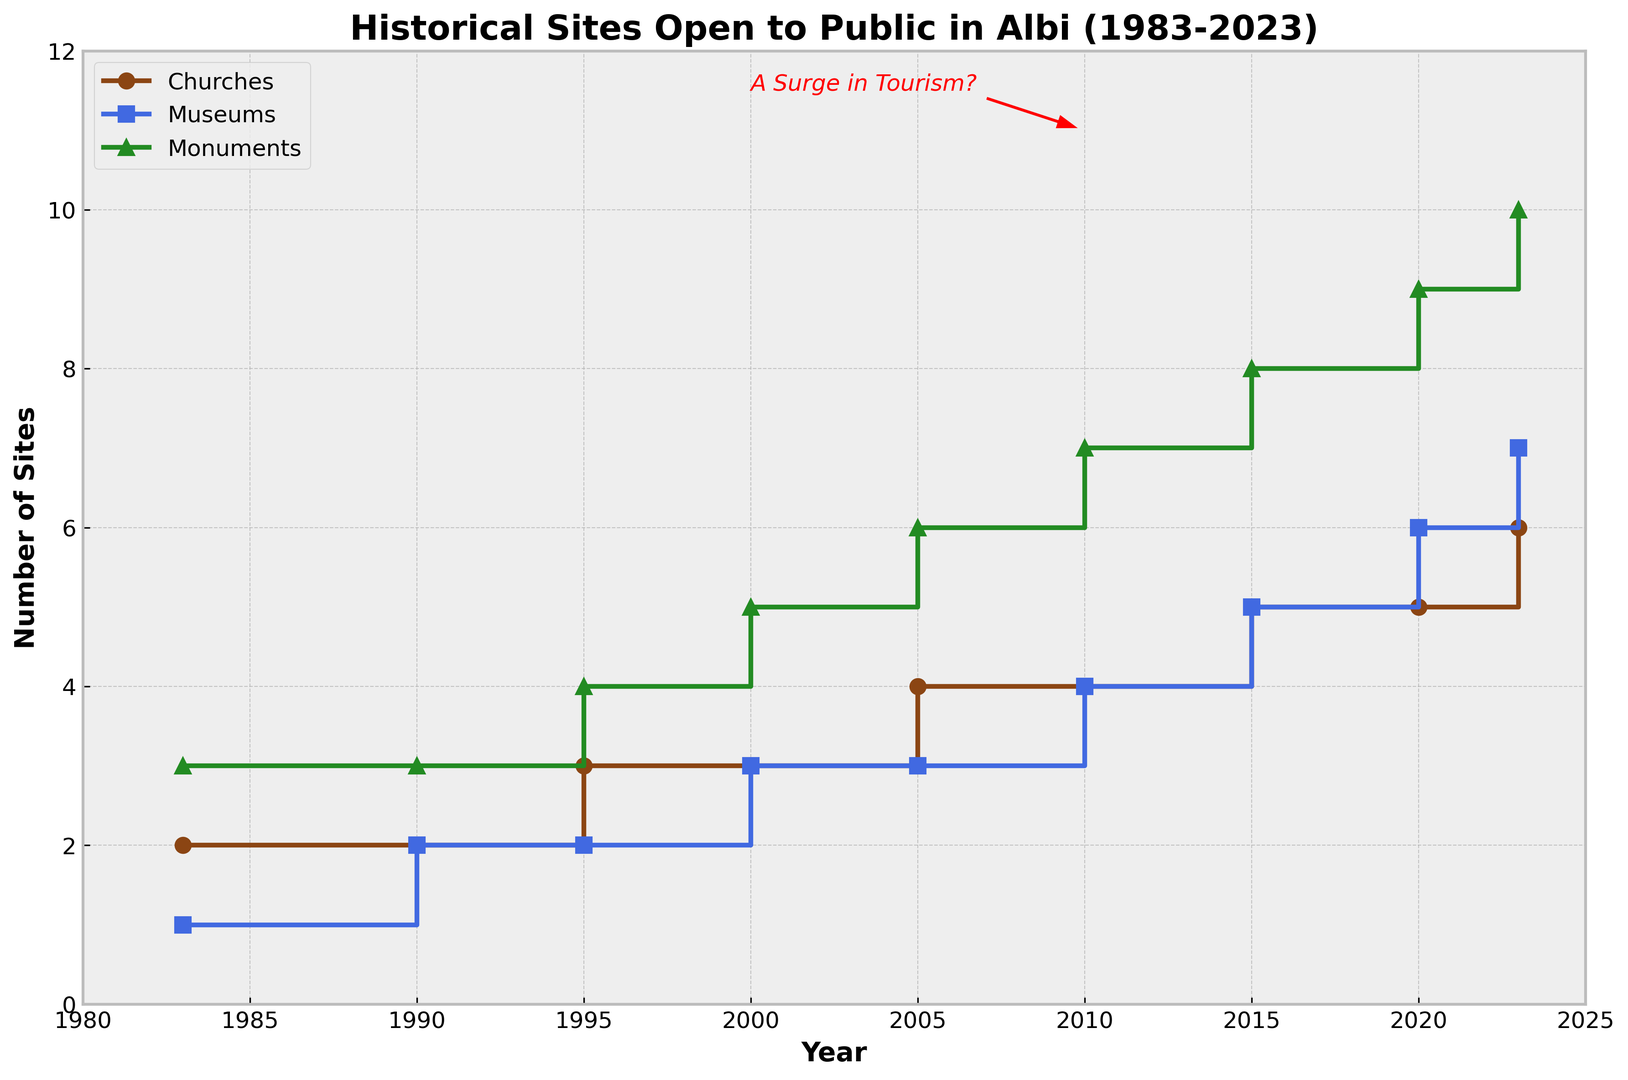When did the number of museums see an increase from 2 to 3? The plot shows a step increase for museums between 1990 and 2000. Thus, the increase must have occurred in 2000.
Answer: 2000 Which type of historical site had the highest number by 2023? The 'Monuments' category reached the highest number by 2023, showing a value of 10 compared to 6 Churches and 7 Museums.
Answer: Monuments What is the total number of churches, museums, and monuments open to the public in 2023? Adding the numbers for 2023: 6 Churches + 7 Museums + 10 Monuments equals 23.
Answer: 23 Between which years did churches see the first increase? The plot shows a step increase for churches between 1990 and 1995.
Answer: 1995 How many total historical sites were open to the public by 1990, and how does this compare to the total in 2023? Summing the 1990 figures: 2 Churches, 2 Museums, 3 Monuments equal 7. For 2023: 6 Churches, 7 Museums, 10 Monuments equal 23. The difference is 23 - 7 = 16.
Answer: 16 Which year saw the highest increase in the number of monuments? The plot shows the number of monuments increased consistently but the difference of 2 monuments between 2000 and 2005 (from 5 to 6) is significant compared to other years.
Answer: 2005 What is the average increase in the number of museums every five years from 1983 to 2023? The number of museums increased from 1 in 1983 to 7 in 2023, which is an increase of 6 museums over 40 years. Dividing 6 by 8 (40 years / 5 years) gives an average increase of 0.75 museums every five years.
Answer: 0.75 Identify one period where all three types of historical sites saw an increase simultaneously. From 2005 to 2010, all three types of historical sites—Churches (4 to 4), Museums (3 to 4), and Monuments (6 to 7)—increased.
Answer: 2005-2010 When did the number of churches reach 5? The number of churches jumped to 5 in the year 2015 as observed in the stairs plot.
Answer: 2015 